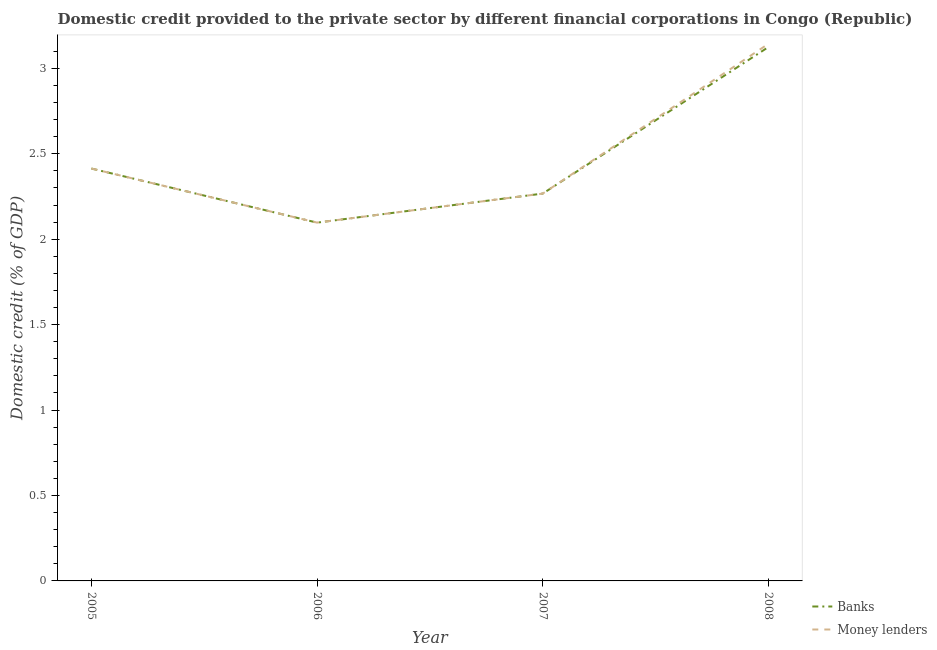How many different coloured lines are there?
Provide a succinct answer. 2. Does the line corresponding to domestic credit provided by banks intersect with the line corresponding to domestic credit provided by money lenders?
Provide a short and direct response. Yes. Is the number of lines equal to the number of legend labels?
Ensure brevity in your answer.  Yes. What is the domestic credit provided by banks in 2007?
Offer a terse response. 2.27. Across all years, what is the maximum domestic credit provided by banks?
Provide a short and direct response. 3.13. Across all years, what is the minimum domestic credit provided by banks?
Your response must be concise. 2.1. In which year was the domestic credit provided by banks maximum?
Provide a succinct answer. 2008. In which year was the domestic credit provided by money lenders minimum?
Make the answer very short. 2006. What is the total domestic credit provided by banks in the graph?
Make the answer very short. 9.9. What is the difference between the domestic credit provided by money lenders in 2006 and that in 2007?
Keep it short and to the point. -0.17. What is the difference between the domestic credit provided by banks in 2006 and the domestic credit provided by money lenders in 2007?
Make the answer very short. -0.17. What is the average domestic credit provided by money lenders per year?
Your answer should be compact. 2.48. In how many years, is the domestic credit provided by money lenders greater than 0.9 %?
Provide a succinct answer. 4. What is the ratio of the domestic credit provided by money lenders in 2006 to that in 2008?
Ensure brevity in your answer.  0.67. Is the domestic credit provided by banks in 2006 less than that in 2007?
Offer a very short reply. Yes. Is the difference between the domestic credit provided by banks in 2005 and 2008 greater than the difference between the domestic credit provided by money lenders in 2005 and 2008?
Offer a very short reply. Yes. What is the difference between the highest and the second highest domestic credit provided by banks?
Offer a terse response. 0.71. What is the difference between the highest and the lowest domestic credit provided by money lenders?
Keep it short and to the point. 1.05. In how many years, is the domestic credit provided by money lenders greater than the average domestic credit provided by money lenders taken over all years?
Offer a terse response. 1. Is the sum of the domestic credit provided by money lenders in 2006 and 2007 greater than the maximum domestic credit provided by banks across all years?
Offer a very short reply. Yes. Does the domestic credit provided by money lenders monotonically increase over the years?
Give a very brief answer. No. Is the domestic credit provided by banks strictly less than the domestic credit provided by money lenders over the years?
Your answer should be compact. No. How many lines are there?
Make the answer very short. 2. How many years are there in the graph?
Provide a short and direct response. 4. What is the difference between two consecutive major ticks on the Y-axis?
Keep it short and to the point. 0.5. Are the values on the major ticks of Y-axis written in scientific E-notation?
Keep it short and to the point. No. Does the graph contain any zero values?
Provide a succinct answer. No. How are the legend labels stacked?
Give a very brief answer. Vertical. What is the title of the graph?
Provide a succinct answer. Domestic credit provided to the private sector by different financial corporations in Congo (Republic). What is the label or title of the X-axis?
Provide a short and direct response. Year. What is the label or title of the Y-axis?
Your answer should be very brief. Domestic credit (% of GDP). What is the Domestic credit (% of GDP) in Banks in 2005?
Give a very brief answer. 2.41. What is the Domestic credit (% of GDP) of Money lenders in 2005?
Make the answer very short. 2.41. What is the Domestic credit (% of GDP) in Banks in 2006?
Ensure brevity in your answer.  2.1. What is the Domestic credit (% of GDP) in Money lenders in 2006?
Make the answer very short. 2.1. What is the Domestic credit (% of GDP) in Banks in 2007?
Provide a succinct answer. 2.27. What is the Domestic credit (% of GDP) of Money lenders in 2007?
Provide a short and direct response. 2.27. What is the Domestic credit (% of GDP) of Banks in 2008?
Your response must be concise. 3.13. What is the Domestic credit (% of GDP) in Money lenders in 2008?
Provide a succinct answer. 3.14. Across all years, what is the maximum Domestic credit (% of GDP) in Banks?
Keep it short and to the point. 3.13. Across all years, what is the maximum Domestic credit (% of GDP) of Money lenders?
Ensure brevity in your answer.  3.14. Across all years, what is the minimum Domestic credit (% of GDP) of Banks?
Ensure brevity in your answer.  2.1. Across all years, what is the minimum Domestic credit (% of GDP) of Money lenders?
Your answer should be compact. 2.1. What is the total Domestic credit (% of GDP) of Banks in the graph?
Your answer should be compact. 9.9. What is the total Domestic credit (% of GDP) in Money lenders in the graph?
Ensure brevity in your answer.  9.92. What is the difference between the Domestic credit (% of GDP) in Banks in 2005 and that in 2006?
Provide a short and direct response. 0.32. What is the difference between the Domestic credit (% of GDP) of Money lenders in 2005 and that in 2006?
Make the answer very short. 0.32. What is the difference between the Domestic credit (% of GDP) of Banks in 2005 and that in 2007?
Provide a short and direct response. 0.15. What is the difference between the Domestic credit (% of GDP) of Money lenders in 2005 and that in 2007?
Ensure brevity in your answer.  0.15. What is the difference between the Domestic credit (% of GDP) in Banks in 2005 and that in 2008?
Your response must be concise. -0.71. What is the difference between the Domestic credit (% of GDP) in Money lenders in 2005 and that in 2008?
Keep it short and to the point. -0.73. What is the difference between the Domestic credit (% of GDP) in Banks in 2006 and that in 2007?
Offer a terse response. -0.17. What is the difference between the Domestic credit (% of GDP) in Money lenders in 2006 and that in 2007?
Make the answer very short. -0.17. What is the difference between the Domestic credit (% of GDP) of Banks in 2006 and that in 2008?
Provide a succinct answer. -1.03. What is the difference between the Domestic credit (% of GDP) in Money lenders in 2006 and that in 2008?
Give a very brief answer. -1.05. What is the difference between the Domestic credit (% of GDP) of Banks in 2007 and that in 2008?
Make the answer very short. -0.86. What is the difference between the Domestic credit (% of GDP) in Money lenders in 2007 and that in 2008?
Make the answer very short. -0.88. What is the difference between the Domestic credit (% of GDP) of Banks in 2005 and the Domestic credit (% of GDP) of Money lenders in 2006?
Make the answer very short. 0.32. What is the difference between the Domestic credit (% of GDP) of Banks in 2005 and the Domestic credit (% of GDP) of Money lenders in 2007?
Provide a short and direct response. 0.15. What is the difference between the Domestic credit (% of GDP) of Banks in 2005 and the Domestic credit (% of GDP) of Money lenders in 2008?
Ensure brevity in your answer.  -0.73. What is the difference between the Domestic credit (% of GDP) in Banks in 2006 and the Domestic credit (% of GDP) in Money lenders in 2007?
Your answer should be compact. -0.17. What is the difference between the Domestic credit (% of GDP) in Banks in 2006 and the Domestic credit (% of GDP) in Money lenders in 2008?
Your response must be concise. -1.05. What is the difference between the Domestic credit (% of GDP) in Banks in 2007 and the Domestic credit (% of GDP) in Money lenders in 2008?
Give a very brief answer. -0.88. What is the average Domestic credit (% of GDP) in Banks per year?
Offer a very short reply. 2.48. What is the average Domestic credit (% of GDP) of Money lenders per year?
Keep it short and to the point. 2.48. In the year 2007, what is the difference between the Domestic credit (% of GDP) in Banks and Domestic credit (% of GDP) in Money lenders?
Your response must be concise. 0. In the year 2008, what is the difference between the Domestic credit (% of GDP) of Banks and Domestic credit (% of GDP) of Money lenders?
Provide a short and direct response. -0.02. What is the ratio of the Domestic credit (% of GDP) in Banks in 2005 to that in 2006?
Provide a succinct answer. 1.15. What is the ratio of the Domestic credit (% of GDP) of Money lenders in 2005 to that in 2006?
Make the answer very short. 1.15. What is the ratio of the Domestic credit (% of GDP) of Banks in 2005 to that in 2007?
Offer a very short reply. 1.06. What is the ratio of the Domestic credit (% of GDP) in Money lenders in 2005 to that in 2007?
Keep it short and to the point. 1.06. What is the ratio of the Domestic credit (% of GDP) of Banks in 2005 to that in 2008?
Offer a very short reply. 0.77. What is the ratio of the Domestic credit (% of GDP) of Money lenders in 2005 to that in 2008?
Ensure brevity in your answer.  0.77. What is the ratio of the Domestic credit (% of GDP) in Banks in 2006 to that in 2007?
Your answer should be very brief. 0.93. What is the ratio of the Domestic credit (% of GDP) in Money lenders in 2006 to that in 2007?
Make the answer very short. 0.93. What is the ratio of the Domestic credit (% of GDP) in Banks in 2006 to that in 2008?
Provide a succinct answer. 0.67. What is the ratio of the Domestic credit (% of GDP) in Money lenders in 2006 to that in 2008?
Your answer should be compact. 0.67. What is the ratio of the Domestic credit (% of GDP) in Banks in 2007 to that in 2008?
Offer a terse response. 0.73. What is the ratio of the Domestic credit (% of GDP) of Money lenders in 2007 to that in 2008?
Your response must be concise. 0.72. What is the difference between the highest and the second highest Domestic credit (% of GDP) in Banks?
Keep it short and to the point. 0.71. What is the difference between the highest and the second highest Domestic credit (% of GDP) in Money lenders?
Your answer should be very brief. 0.73. What is the difference between the highest and the lowest Domestic credit (% of GDP) of Banks?
Provide a succinct answer. 1.03. What is the difference between the highest and the lowest Domestic credit (% of GDP) in Money lenders?
Give a very brief answer. 1.05. 